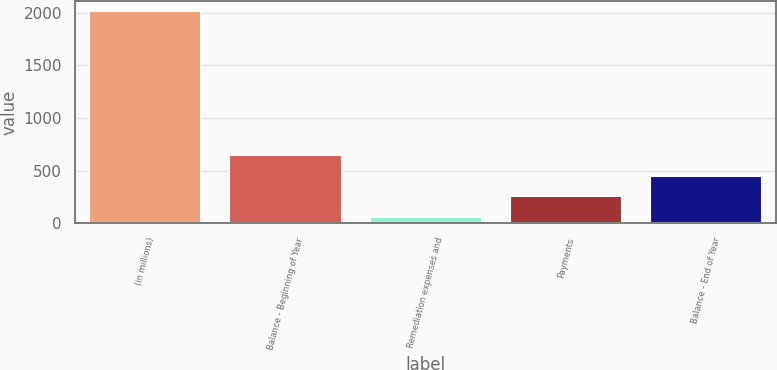<chart> <loc_0><loc_0><loc_500><loc_500><bar_chart><fcel>(in millions)<fcel>Balance - Beginning of Year<fcel>Remediation expenses and<fcel>Payments<fcel>Balance - End of Year<nl><fcel>2013<fcel>645.9<fcel>60<fcel>255.3<fcel>450.6<nl></chart> 